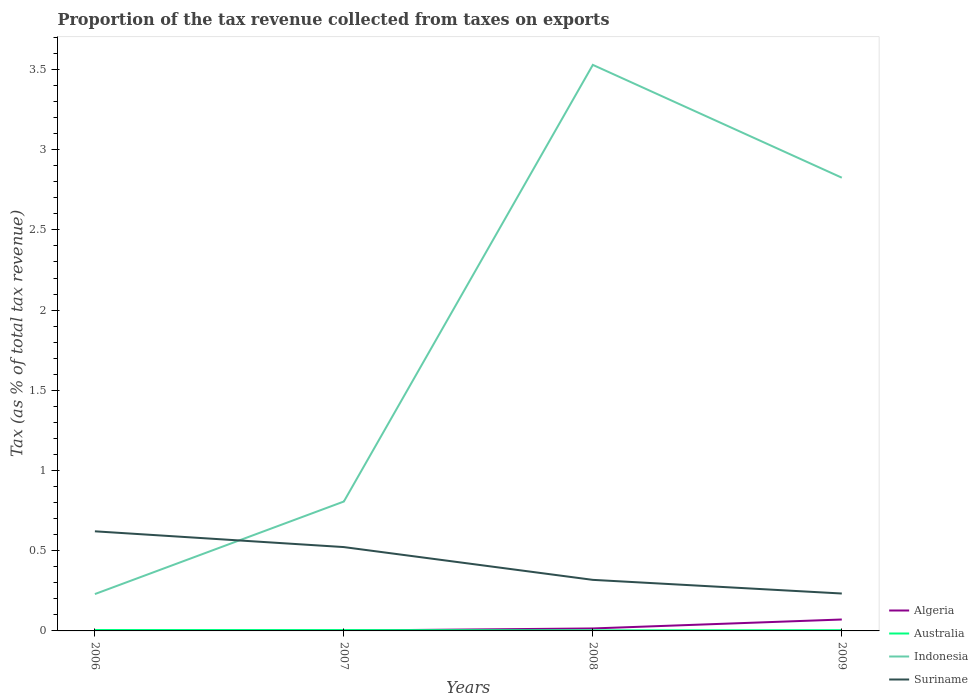How many different coloured lines are there?
Keep it short and to the point. 4. Across all years, what is the maximum proportion of the tax revenue collected in Suriname?
Provide a short and direct response. 0.23. In which year was the proportion of the tax revenue collected in Algeria maximum?
Provide a short and direct response. 2006. What is the total proportion of the tax revenue collected in Indonesia in the graph?
Your answer should be very brief. 0.7. What is the difference between the highest and the second highest proportion of the tax revenue collected in Australia?
Your answer should be very brief. 0. What is the difference between the highest and the lowest proportion of the tax revenue collected in Algeria?
Provide a short and direct response. 1. How many years are there in the graph?
Provide a succinct answer. 4. What is the title of the graph?
Provide a succinct answer. Proportion of the tax revenue collected from taxes on exports. Does "Heavily indebted poor countries" appear as one of the legend labels in the graph?
Ensure brevity in your answer.  No. What is the label or title of the Y-axis?
Keep it short and to the point. Tax (as % of total tax revenue). What is the Tax (as % of total tax revenue) of Algeria in 2006?
Your answer should be very brief. 0. What is the Tax (as % of total tax revenue) in Australia in 2006?
Give a very brief answer. 0.01. What is the Tax (as % of total tax revenue) of Indonesia in 2006?
Your answer should be compact. 0.23. What is the Tax (as % of total tax revenue) in Suriname in 2006?
Keep it short and to the point. 0.62. What is the Tax (as % of total tax revenue) of Algeria in 2007?
Your answer should be very brief. 0. What is the Tax (as % of total tax revenue) in Australia in 2007?
Your answer should be compact. 0.01. What is the Tax (as % of total tax revenue) of Indonesia in 2007?
Give a very brief answer. 0.81. What is the Tax (as % of total tax revenue) of Suriname in 2007?
Offer a terse response. 0.52. What is the Tax (as % of total tax revenue) of Algeria in 2008?
Provide a succinct answer. 0.02. What is the Tax (as % of total tax revenue) of Australia in 2008?
Your answer should be very brief. 0. What is the Tax (as % of total tax revenue) in Indonesia in 2008?
Keep it short and to the point. 3.53. What is the Tax (as % of total tax revenue) in Suriname in 2008?
Provide a short and direct response. 0.32. What is the Tax (as % of total tax revenue) of Algeria in 2009?
Your answer should be very brief. 0.07. What is the Tax (as % of total tax revenue) in Australia in 2009?
Give a very brief answer. 0. What is the Tax (as % of total tax revenue) in Indonesia in 2009?
Your answer should be compact. 2.83. What is the Tax (as % of total tax revenue) of Suriname in 2009?
Your answer should be compact. 0.23. Across all years, what is the maximum Tax (as % of total tax revenue) of Algeria?
Keep it short and to the point. 0.07. Across all years, what is the maximum Tax (as % of total tax revenue) of Australia?
Give a very brief answer. 0.01. Across all years, what is the maximum Tax (as % of total tax revenue) of Indonesia?
Offer a terse response. 3.53. Across all years, what is the maximum Tax (as % of total tax revenue) of Suriname?
Provide a short and direct response. 0.62. Across all years, what is the minimum Tax (as % of total tax revenue) of Algeria?
Give a very brief answer. 0. Across all years, what is the minimum Tax (as % of total tax revenue) of Australia?
Your answer should be compact. 0. Across all years, what is the minimum Tax (as % of total tax revenue) of Indonesia?
Give a very brief answer. 0.23. Across all years, what is the minimum Tax (as % of total tax revenue) in Suriname?
Make the answer very short. 0.23. What is the total Tax (as % of total tax revenue) of Algeria in the graph?
Provide a short and direct response. 0.09. What is the total Tax (as % of total tax revenue) in Australia in the graph?
Offer a very short reply. 0.02. What is the total Tax (as % of total tax revenue) of Indonesia in the graph?
Your response must be concise. 7.39. What is the total Tax (as % of total tax revenue) of Suriname in the graph?
Give a very brief answer. 1.7. What is the difference between the Tax (as % of total tax revenue) in Algeria in 2006 and that in 2007?
Keep it short and to the point. -0. What is the difference between the Tax (as % of total tax revenue) of Australia in 2006 and that in 2007?
Provide a succinct answer. 0. What is the difference between the Tax (as % of total tax revenue) of Indonesia in 2006 and that in 2007?
Your answer should be compact. -0.58. What is the difference between the Tax (as % of total tax revenue) of Suriname in 2006 and that in 2007?
Keep it short and to the point. 0.1. What is the difference between the Tax (as % of total tax revenue) in Algeria in 2006 and that in 2008?
Offer a terse response. -0.01. What is the difference between the Tax (as % of total tax revenue) of Australia in 2006 and that in 2008?
Offer a very short reply. 0. What is the difference between the Tax (as % of total tax revenue) in Indonesia in 2006 and that in 2008?
Ensure brevity in your answer.  -3.3. What is the difference between the Tax (as % of total tax revenue) of Suriname in 2006 and that in 2008?
Give a very brief answer. 0.3. What is the difference between the Tax (as % of total tax revenue) in Algeria in 2006 and that in 2009?
Ensure brevity in your answer.  -0.07. What is the difference between the Tax (as % of total tax revenue) in Australia in 2006 and that in 2009?
Your answer should be very brief. 0. What is the difference between the Tax (as % of total tax revenue) of Indonesia in 2006 and that in 2009?
Your answer should be very brief. -2.6. What is the difference between the Tax (as % of total tax revenue) of Suriname in 2006 and that in 2009?
Offer a very short reply. 0.39. What is the difference between the Tax (as % of total tax revenue) of Algeria in 2007 and that in 2008?
Provide a short and direct response. -0.01. What is the difference between the Tax (as % of total tax revenue) in Australia in 2007 and that in 2008?
Provide a succinct answer. 0. What is the difference between the Tax (as % of total tax revenue) in Indonesia in 2007 and that in 2008?
Your response must be concise. -2.72. What is the difference between the Tax (as % of total tax revenue) in Suriname in 2007 and that in 2008?
Ensure brevity in your answer.  0.2. What is the difference between the Tax (as % of total tax revenue) in Algeria in 2007 and that in 2009?
Keep it short and to the point. -0.07. What is the difference between the Tax (as % of total tax revenue) in Australia in 2007 and that in 2009?
Offer a very short reply. 0. What is the difference between the Tax (as % of total tax revenue) in Indonesia in 2007 and that in 2009?
Give a very brief answer. -2.02. What is the difference between the Tax (as % of total tax revenue) of Suriname in 2007 and that in 2009?
Offer a very short reply. 0.29. What is the difference between the Tax (as % of total tax revenue) of Algeria in 2008 and that in 2009?
Your answer should be compact. -0.06. What is the difference between the Tax (as % of total tax revenue) in Australia in 2008 and that in 2009?
Provide a succinct answer. -0. What is the difference between the Tax (as % of total tax revenue) of Indonesia in 2008 and that in 2009?
Offer a terse response. 0.7. What is the difference between the Tax (as % of total tax revenue) of Suriname in 2008 and that in 2009?
Offer a terse response. 0.09. What is the difference between the Tax (as % of total tax revenue) of Algeria in 2006 and the Tax (as % of total tax revenue) of Australia in 2007?
Ensure brevity in your answer.  -0. What is the difference between the Tax (as % of total tax revenue) in Algeria in 2006 and the Tax (as % of total tax revenue) in Indonesia in 2007?
Your answer should be very brief. -0.81. What is the difference between the Tax (as % of total tax revenue) in Algeria in 2006 and the Tax (as % of total tax revenue) in Suriname in 2007?
Ensure brevity in your answer.  -0.52. What is the difference between the Tax (as % of total tax revenue) in Australia in 2006 and the Tax (as % of total tax revenue) in Indonesia in 2007?
Offer a terse response. -0.8. What is the difference between the Tax (as % of total tax revenue) in Australia in 2006 and the Tax (as % of total tax revenue) in Suriname in 2007?
Give a very brief answer. -0.52. What is the difference between the Tax (as % of total tax revenue) in Indonesia in 2006 and the Tax (as % of total tax revenue) in Suriname in 2007?
Make the answer very short. -0.29. What is the difference between the Tax (as % of total tax revenue) in Algeria in 2006 and the Tax (as % of total tax revenue) in Australia in 2008?
Offer a terse response. -0. What is the difference between the Tax (as % of total tax revenue) of Algeria in 2006 and the Tax (as % of total tax revenue) of Indonesia in 2008?
Keep it short and to the point. -3.53. What is the difference between the Tax (as % of total tax revenue) in Algeria in 2006 and the Tax (as % of total tax revenue) in Suriname in 2008?
Your response must be concise. -0.32. What is the difference between the Tax (as % of total tax revenue) in Australia in 2006 and the Tax (as % of total tax revenue) in Indonesia in 2008?
Ensure brevity in your answer.  -3.52. What is the difference between the Tax (as % of total tax revenue) of Australia in 2006 and the Tax (as % of total tax revenue) of Suriname in 2008?
Keep it short and to the point. -0.31. What is the difference between the Tax (as % of total tax revenue) in Indonesia in 2006 and the Tax (as % of total tax revenue) in Suriname in 2008?
Keep it short and to the point. -0.09. What is the difference between the Tax (as % of total tax revenue) of Algeria in 2006 and the Tax (as % of total tax revenue) of Australia in 2009?
Offer a terse response. -0. What is the difference between the Tax (as % of total tax revenue) in Algeria in 2006 and the Tax (as % of total tax revenue) in Indonesia in 2009?
Provide a short and direct response. -2.82. What is the difference between the Tax (as % of total tax revenue) in Algeria in 2006 and the Tax (as % of total tax revenue) in Suriname in 2009?
Your answer should be compact. -0.23. What is the difference between the Tax (as % of total tax revenue) of Australia in 2006 and the Tax (as % of total tax revenue) of Indonesia in 2009?
Your answer should be compact. -2.82. What is the difference between the Tax (as % of total tax revenue) of Australia in 2006 and the Tax (as % of total tax revenue) of Suriname in 2009?
Provide a succinct answer. -0.23. What is the difference between the Tax (as % of total tax revenue) of Indonesia in 2006 and the Tax (as % of total tax revenue) of Suriname in 2009?
Make the answer very short. -0. What is the difference between the Tax (as % of total tax revenue) in Algeria in 2007 and the Tax (as % of total tax revenue) in Australia in 2008?
Provide a succinct answer. -0. What is the difference between the Tax (as % of total tax revenue) of Algeria in 2007 and the Tax (as % of total tax revenue) of Indonesia in 2008?
Your answer should be very brief. -3.53. What is the difference between the Tax (as % of total tax revenue) in Algeria in 2007 and the Tax (as % of total tax revenue) in Suriname in 2008?
Provide a short and direct response. -0.32. What is the difference between the Tax (as % of total tax revenue) in Australia in 2007 and the Tax (as % of total tax revenue) in Indonesia in 2008?
Your answer should be compact. -3.52. What is the difference between the Tax (as % of total tax revenue) of Australia in 2007 and the Tax (as % of total tax revenue) of Suriname in 2008?
Ensure brevity in your answer.  -0.31. What is the difference between the Tax (as % of total tax revenue) of Indonesia in 2007 and the Tax (as % of total tax revenue) of Suriname in 2008?
Your answer should be very brief. 0.49. What is the difference between the Tax (as % of total tax revenue) of Algeria in 2007 and the Tax (as % of total tax revenue) of Australia in 2009?
Your response must be concise. -0. What is the difference between the Tax (as % of total tax revenue) of Algeria in 2007 and the Tax (as % of total tax revenue) of Indonesia in 2009?
Offer a terse response. -2.82. What is the difference between the Tax (as % of total tax revenue) in Algeria in 2007 and the Tax (as % of total tax revenue) in Suriname in 2009?
Provide a succinct answer. -0.23. What is the difference between the Tax (as % of total tax revenue) in Australia in 2007 and the Tax (as % of total tax revenue) in Indonesia in 2009?
Offer a terse response. -2.82. What is the difference between the Tax (as % of total tax revenue) of Australia in 2007 and the Tax (as % of total tax revenue) of Suriname in 2009?
Offer a very short reply. -0.23. What is the difference between the Tax (as % of total tax revenue) in Indonesia in 2007 and the Tax (as % of total tax revenue) in Suriname in 2009?
Offer a very short reply. 0.57. What is the difference between the Tax (as % of total tax revenue) of Algeria in 2008 and the Tax (as % of total tax revenue) of Australia in 2009?
Provide a short and direct response. 0.01. What is the difference between the Tax (as % of total tax revenue) of Algeria in 2008 and the Tax (as % of total tax revenue) of Indonesia in 2009?
Give a very brief answer. -2.81. What is the difference between the Tax (as % of total tax revenue) in Algeria in 2008 and the Tax (as % of total tax revenue) in Suriname in 2009?
Keep it short and to the point. -0.22. What is the difference between the Tax (as % of total tax revenue) in Australia in 2008 and the Tax (as % of total tax revenue) in Indonesia in 2009?
Offer a very short reply. -2.82. What is the difference between the Tax (as % of total tax revenue) in Australia in 2008 and the Tax (as % of total tax revenue) in Suriname in 2009?
Offer a terse response. -0.23. What is the difference between the Tax (as % of total tax revenue) in Indonesia in 2008 and the Tax (as % of total tax revenue) in Suriname in 2009?
Keep it short and to the point. 3.3. What is the average Tax (as % of total tax revenue) in Algeria per year?
Give a very brief answer. 0.02. What is the average Tax (as % of total tax revenue) of Australia per year?
Your answer should be compact. 0. What is the average Tax (as % of total tax revenue) of Indonesia per year?
Offer a very short reply. 1.85. What is the average Tax (as % of total tax revenue) in Suriname per year?
Provide a short and direct response. 0.42. In the year 2006, what is the difference between the Tax (as % of total tax revenue) in Algeria and Tax (as % of total tax revenue) in Australia?
Keep it short and to the point. -0.01. In the year 2006, what is the difference between the Tax (as % of total tax revenue) of Algeria and Tax (as % of total tax revenue) of Indonesia?
Give a very brief answer. -0.23. In the year 2006, what is the difference between the Tax (as % of total tax revenue) of Algeria and Tax (as % of total tax revenue) of Suriname?
Offer a terse response. -0.62. In the year 2006, what is the difference between the Tax (as % of total tax revenue) in Australia and Tax (as % of total tax revenue) in Indonesia?
Your response must be concise. -0.22. In the year 2006, what is the difference between the Tax (as % of total tax revenue) in Australia and Tax (as % of total tax revenue) in Suriname?
Your answer should be very brief. -0.62. In the year 2006, what is the difference between the Tax (as % of total tax revenue) in Indonesia and Tax (as % of total tax revenue) in Suriname?
Offer a very short reply. -0.39. In the year 2007, what is the difference between the Tax (as % of total tax revenue) of Algeria and Tax (as % of total tax revenue) of Australia?
Your answer should be compact. -0. In the year 2007, what is the difference between the Tax (as % of total tax revenue) of Algeria and Tax (as % of total tax revenue) of Indonesia?
Your answer should be compact. -0.8. In the year 2007, what is the difference between the Tax (as % of total tax revenue) in Algeria and Tax (as % of total tax revenue) in Suriname?
Give a very brief answer. -0.52. In the year 2007, what is the difference between the Tax (as % of total tax revenue) of Australia and Tax (as % of total tax revenue) of Indonesia?
Ensure brevity in your answer.  -0.8. In the year 2007, what is the difference between the Tax (as % of total tax revenue) of Australia and Tax (as % of total tax revenue) of Suriname?
Your answer should be very brief. -0.52. In the year 2007, what is the difference between the Tax (as % of total tax revenue) of Indonesia and Tax (as % of total tax revenue) of Suriname?
Give a very brief answer. 0.28. In the year 2008, what is the difference between the Tax (as % of total tax revenue) in Algeria and Tax (as % of total tax revenue) in Australia?
Your answer should be very brief. 0.01. In the year 2008, what is the difference between the Tax (as % of total tax revenue) in Algeria and Tax (as % of total tax revenue) in Indonesia?
Keep it short and to the point. -3.51. In the year 2008, what is the difference between the Tax (as % of total tax revenue) in Algeria and Tax (as % of total tax revenue) in Suriname?
Offer a very short reply. -0.3. In the year 2008, what is the difference between the Tax (as % of total tax revenue) in Australia and Tax (as % of total tax revenue) in Indonesia?
Ensure brevity in your answer.  -3.53. In the year 2008, what is the difference between the Tax (as % of total tax revenue) of Australia and Tax (as % of total tax revenue) of Suriname?
Your answer should be compact. -0.31. In the year 2008, what is the difference between the Tax (as % of total tax revenue) of Indonesia and Tax (as % of total tax revenue) of Suriname?
Provide a succinct answer. 3.21. In the year 2009, what is the difference between the Tax (as % of total tax revenue) in Algeria and Tax (as % of total tax revenue) in Australia?
Provide a succinct answer. 0.07. In the year 2009, what is the difference between the Tax (as % of total tax revenue) in Algeria and Tax (as % of total tax revenue) in Indonesia?
Provide a short and direct response. -2.75. In the year 2009, what is the difference between the Tax (as % of total tax revenue) of Algeria and Tax (as % of total tax revenue) of Suriname?
Offer a very short reply. -0.16. In the year 2009, what is the difference between the Tax (as % of total tax revenue) of Australia and Tax (as % of total tax revenue) of Indonesia?
Offer a terse response. -2.82. In the year 2009, what is the difference between the Tax (as % of total tax revenue) in Australia and Tax (as % of total tax revenue) in Suriname?
Your response must be concise. -0.23. In the year 2009, what is the difference between the Tax (as % of total tax revenue) in Indonesia and Tax (as % of total tax revenue) in Suriname?
Give a very brief answer. 2.59. What is the ratio of the Tax (as % of total tax revenue) of Algeria in 2006 to that in 2007?
Offer a very short reply. 0.25. What is the ratio of the Tax (as % of total tax revenue) of Australia in 2006 to that in 2007?
Provide a succinct answer. 1.07. What is the ratio of the Tax (as % of total tax revenue) in Indonesia in 2006 to that in 2007?
Make the answer very short. 0.28. What is the ratio of the Tax (as % of total tax revenue) of Suriname in 2006 to that in 2007?
Offer a terse response. 1.19. What is the ratio of the Tax (as % of total tax revenue) in Algeria in 2006 to that in 2008?
Provide a short and direct response. 0.04. What is the ratio of the Tax (as % of total tax revenue) in Australia in 2006 to that in 2008?
Ensure brevity in your answer.  1.63. What is the ratio of the Tax (as % of total tax revenue) in Indonesia in 2006 to that in 2008?
Give a very brief answer. 0.07. What is the ratio of the Tax (as % of total tax revenue) of Suriname in 2006 to that in 2008?
Ensure brevity in your answer.  1.95. What is the ratio of the Tax (as % of total tax revenue) in Algeria in 2006 to that in 2009?
Give a very brief answer. 0.01. What is the ratio of the Tax (as % of total tax revenue) of Australia in 2006 to that in 2009?
Your answer should be very brief. 1.22. What is the ratio of the Tax (as % of total tax revenue) of Indonesia in 2006 to that in 2009?
Your answer should be very brief. 0.08. What is the ratio of the Tax (as % of total tax revenue) of Suriname in 2006 to that in 2009?
Your response must be concise. 2.66. What is the ratio of the Tax (as % of total tax revenue) of Algeria in 2007 to that in 2008?
Your answer should be compact. 0.15. What is the ratio of the Tax (as % of total tax revenue) of Australia in 2007 to that in 2008?
Your answer should be compact. 1.53. What is the ratio of the Tax (as % of total tax revenue) in Indonesia in 2007 to that in 2008?
Ensure brevity in your answer.  0.23. What is the ratio of the Tax (as % of total tax revenue) in Suriname in 2007 to that in 2008?
Keep it short and to the point. 1.64. What is the ratio of the Tax (as % of total tax revenue) in Algeria in 2007 to that in 2009?
Your response must be concise. 0.03. What is the ratio of the Tax (as % of total tax revenue) in Australia in 2007 to that in 2009?
Your response must be concise. 1.14. What is the ratio of the Tax (as % of total tax revenue) in Indonesia in 2007 to that in 2009?
Offer a very short reply. 0.29. What is the ratio of the Tax (as % of total tax revenue) of Suriname in 2007 to that in 2009?
Your response must be concise. 2.24. What is the ratio of the Tax (as % of total tax revenue) in Algeria in 2008 to that in 2009?
Offer a terse response. 0.22. What is the ratio of the Tax (as % of total tax revenue) in Australia in 2008 to that in 2009?
Keep it short and to the point. 0.75. What is the ratio of the Tax (as % of total tax revenue) of Indonesia in 2008 to that in 2009?
Your answer should be very brief. 1.25. What is the ratio of the Tax (as % of total tax revenue) of Suriname in 2008 to that in 2009?
Your answer should be very brief. 1.37. What is the difference between the highest and the second highest Tax (as % of total tax revenue) in Algeria?
Keep it short and to the point. 0.06. What is the difference between the highest and the second highest Tax (as % of total tax revenue) of Australia?
Provide a short and direct response. 0. What is the difference between the highest and the second highest Tax (as % of total tax revenue) in Indonesia?
Provide a succinct answer. 0.7. What is the difference between the highest and the second highest Tax (as % of total tax revenue) in Suriname?
Make the answer very short. 0.1. What is the difference between the highest and the lowest Tax (as % of total tax revenue) in Algeria?
Your answer should be very brief. 0.07. What is the difference between the highest and the lowest Tax (as % of total tax revenue) in Australia?
Your answer should be very brief. 0. What is the difference between the highest and the lowest Tax (as % of total tax revenue) of Indonesia?
Your response must be concise. 3.3. What is the difference between the highest and the lowest Tax (as % of total tax revenue) of Suriname?
Keep it short and to the point. 0.39. 